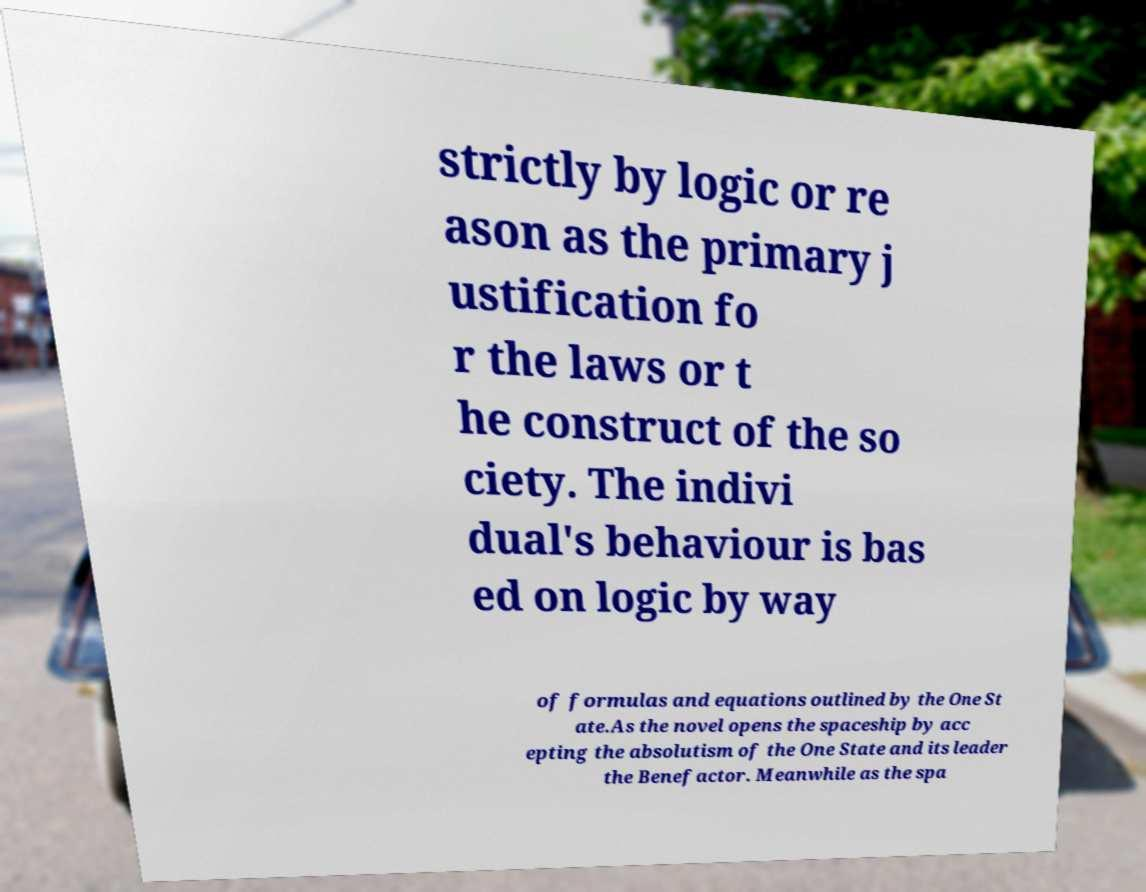Could you assist in decoding the text presented in this image and type it out clearly? strictly by logic or re ason as the primary j ustification fo r the laws or t he construct of the so ciety. The indivi dual's behaviour is bas ed on logic by way of formulas and equations outlined by the One St ate.As the novel opens the spaceship by acc epting the absolutism of the One State and its leader the Benefactor. Meanwhile as the spa 